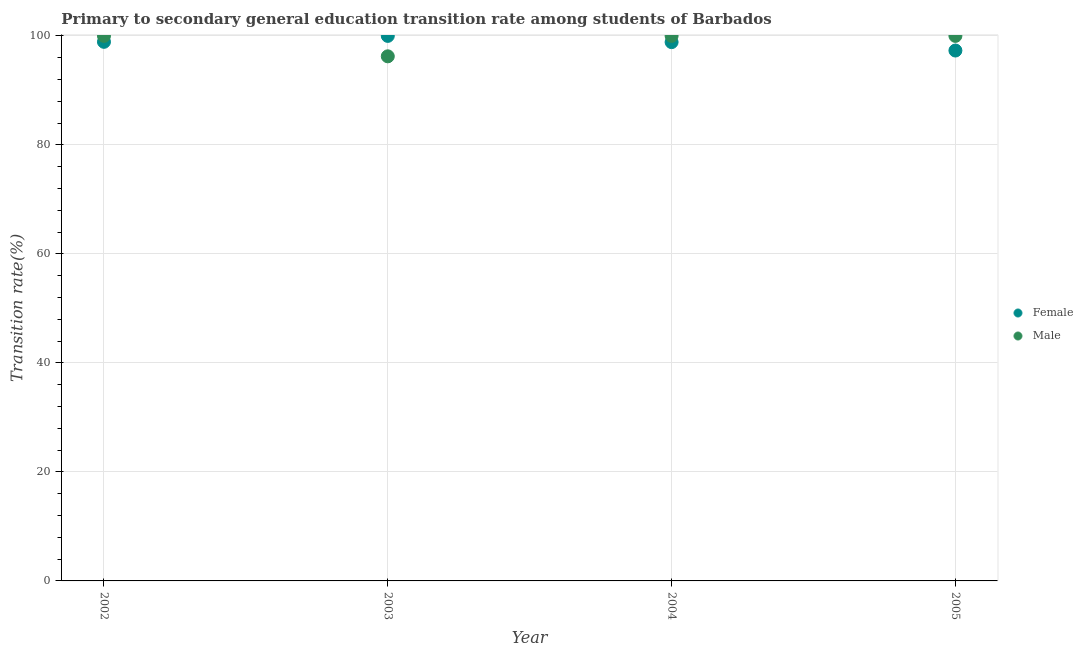Is the number of dotlines equal to the number of legend labels?
Offer a terse response. Yes. Across all years, what is the maximum transition rate among male students?
Make the answer very short. 100. Across all years, what is the minimum transition rate among male students?
Keep it short and to the point. 96.25. What is the total transition rate among male students in the graph?
Offer a terse response. 396.25. What is the difference between the transition rate among female students in 2002 and that in 2005?
Your answer should be very brief. 1.6. What is the difference between the transition rate among male students in 2002 and the transition rate among female students in 2005?
Your answer should be compact. 2.69. What is the average transition rate among male students per year?
Give a very brief answer. 99.06. In the year 2002, what is the difference between the transition rate among male students and transition rate among female students?
Keep it short and to the point. 1.09. What is the ratio of the transition rate among female students in 2002 to that in 2004?
Make the answer very short. 1. Is the transition rate among male students in 2003 less than that in 2004?
Your answer should be compact. Yes. Is the difference between the transition rate among female students in 2002 and 2003 greater than the difference between the transition rate among male students in 2002 and 2003?
Offer a terse response. No. What is the difference between the highest and the lowest transition rate among male students?
Provide a succinct answer. 3.75. In how many years, is the transition rate among female students greater than the average transition rate among female students taken over all years?
Your response must be concise. 3. Does the transition rate among female students monotonically increase over the years?
Your answer should be very brief. No. Is the transition rate among male students strictly greater than the transition rate among female students over the years?
Ensure brevity in your answer.  No. What is the difference between two consecutive major ticks on the Y-axis?
Offer a very short reply. 20. Are the values on the major ticks of Y-axis written in scientific E-notation?
Provide a succinct answer. No. Does the graph contain any zero values?
Make the answer very short. No. Where does the legend appear in the graph?
Your response must be concise. Center right. What is the title of the graph?
Offer a very short reply. Primary to secondary general education transition rate among students of Barbados. Does "By country of asylum" appear as one of the legend labels in the graph?
Ensure brevity in your answer.  No. What is the label or title of the Y-axis?
Provide a succinct answer. Transition rate(%). What is the Transition rate(%) in Female in 2002?
Give a very brief answer. 98.91. What is the Transition rate(%) in Male in 2003?
Give a very brief answer. 96.25. What is the Transition rate(%) in Female in 2004?
Offer a terse response. 98.86. What is the Transition rate(%) of Male in 2004?
Make the answer very short. 100. What is the Transition rate(%) in Female in 2005?
Keep it short and to the point. 97.31. Across all years, what is the minimum Transition rate(%) in Female?
Ensure brevity in your answer.  97.31. Across all years, what is the minimum Transition rate(%) in Male?
Ensure brevity in your answer.  96.25. What is the total Transition rate(%) of Female in the graph?
Your response must be concise. 395.08. What is the total Transition rate(%) in Male in the graph?
Give a very brief answer. 396.25. What is the difference between the Transition rate(%) in Female in 2002 and that in 2003?
Your response must be concise. -1.09. What is the difference between the Transition rate(%) of Male in 2002 and that in 2003?
Your response must be concise. 3.75. What is the difference between the Transition rate(%) of Female in 2002 and that in 2004?
Ensure brevity in your answer.  0.05. What is the difference between the Transition rate(%) in Male in 2002 and that in 2004?
Make the answer very short. 0. What is the difference between the Transition rate(%) in Female in 2002 and that in 2005?
Your response must be concise. 1.6. What is the difference between the Transition rate(%) of Female in 2003 and that in 2004?
Your answer should be very brief. 1.14. What is the difference between the Transition rate(%) in Male in 2003 and that in 2004?
Your answer should be very brief. -3.75. What is the difference between the Transition rate(%) in Female in 2003 and that in 2005?
Give a very brief answer. 2.69. What is the difference between the Transition rate(%) of Male in 2003 and that in 2005?
Your response must be concise. -3.75. What is the difference between the Transition rate(%) in Female in 2004 and that in 2005?
Offer a very short reply. 1.54. What is the difference between the Transition rate(%) in Female in 2002 and the Transition rate(%) in Male in 2003?
Give a very brief answer. 2.66. What is the difference between the Transition rate(%) of Female in 2002 and the Transition rate(%) of Male in 2004?
Your answer should be very brief. -1.09. What is the difference between the Transition rate(%) of Female in 2002 and the Transition rate(%) of Male in 2005?
Provide a short and direct response. -1.09. What is the difference between the Transition rate(%) of Female in 2003 and the Transition rate(%) of Male in 2005?
Offer a very short reply. 0. What is the difference between the Transition rate(%) of Female in 2004 and the Transition rate(%) of Male in 2005?
Keep it short and to the point. -1.14. What is the average Transition rate(%) in Female per year?
Keep it short and to the point. 98.77. What is the average Transition rate(%) in Male per year?
Your answer should be very brief. 99.06. In the year 2002, what is the difference between the Transition rate(%) in Female and Transition rate(%) in Male?
Provide a short and direct response. -1.09. In the year 2003, what is the difference between the Transition rate(%) of Female and Transition rate(%) of Male?
Offer a very short reply. 3.75. In the year 2004, what is the difference between the Transition rate(%) of Female and Transition rate(%) of Male?
Provide a short and direct response. -1.14. In the year 2005, what is the difference between the Transition rate(%) of Female and Transition rate(%) of Male?
Provide a short and direct response. -2.69. What is the ratio of the Transition rate(%) in Female in 2002 to that in 2003?
Provide a short and direct response. 0.99. What is the ratio of the Transition rate(%) in Male in 2002 to that in 2003?
Your answer should be very brief. 1.04. What is the ratio of the Transition rate(%) of Male in 2002 to that in 2004?
Provide a succinct answer. 1. What is the ratio of the Transition rate(%) in Female in 2002 to that in 2005?
Your answer should be compact. 1.02. What is the ratio of the Transition rate(%) in Female in 2003 to that in 2004?
Offer a terse response. 1.01. What is the ratio of the Transition rate(%) in Male in 2003 to that in 2004?
Ensure brevity in your answer.  0.96. What is the ratio of the Transition rate(%) of Female in 2003 to that in 2005?
Your answer should be very brief. 1.03. What is the ratio of the Transition rate(%) in Male in 2003 to that in 2005?
Provide a succinct answer. 0.96. What is the ratio of the Transition rate(%) in Female in 2004 to that in 2005?
Offer a terse response. 1.02. What is the difference between the highest and the second highest Transition rate(%) of Female?
Your answer should be very brief. 1.09. What is the difference between the highest and the second highest Transition rate(%) of Male?
Give a very brief answer. 0. What is the difference between the highest and the lowest Transition rate(%) of Female?
Make the answer very short. 2.69. What is the difference between the highest and the lowest Transition rate(%) of Male?
Your answer should be very brief. 3.75. 